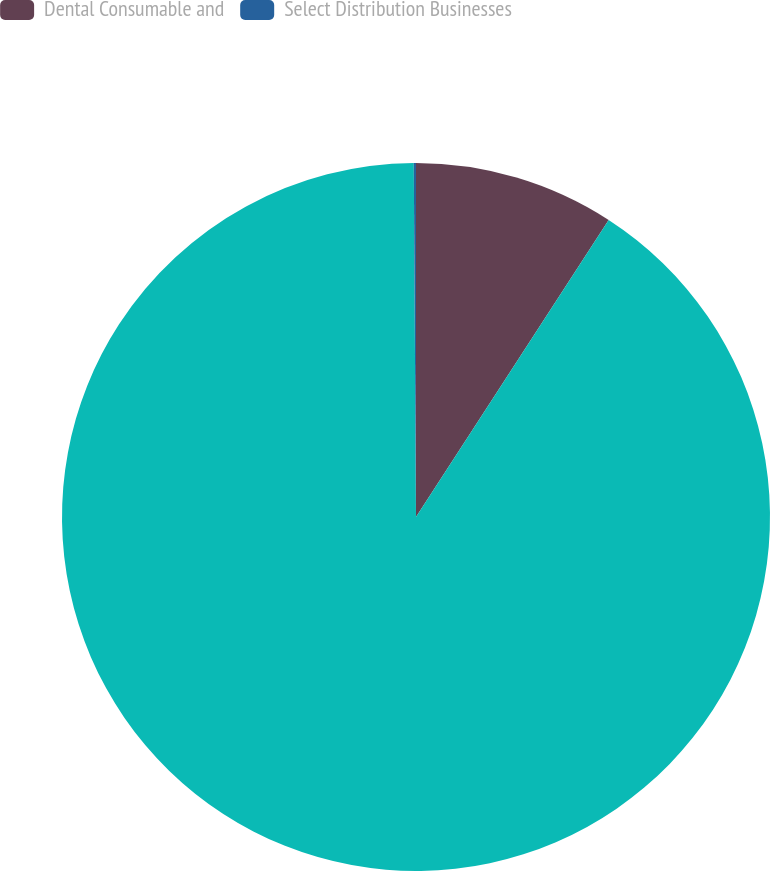<chart> <loc_0><loc_0><loc_500><loc_500><pie_chart><fcel>Dental Consumable and<fcel>Unnamed: 1<fcel>Select Distribution Businesses<nl><fcel>9.16%<fcel>90.74%<fcel>0.1%<nl></chart> 